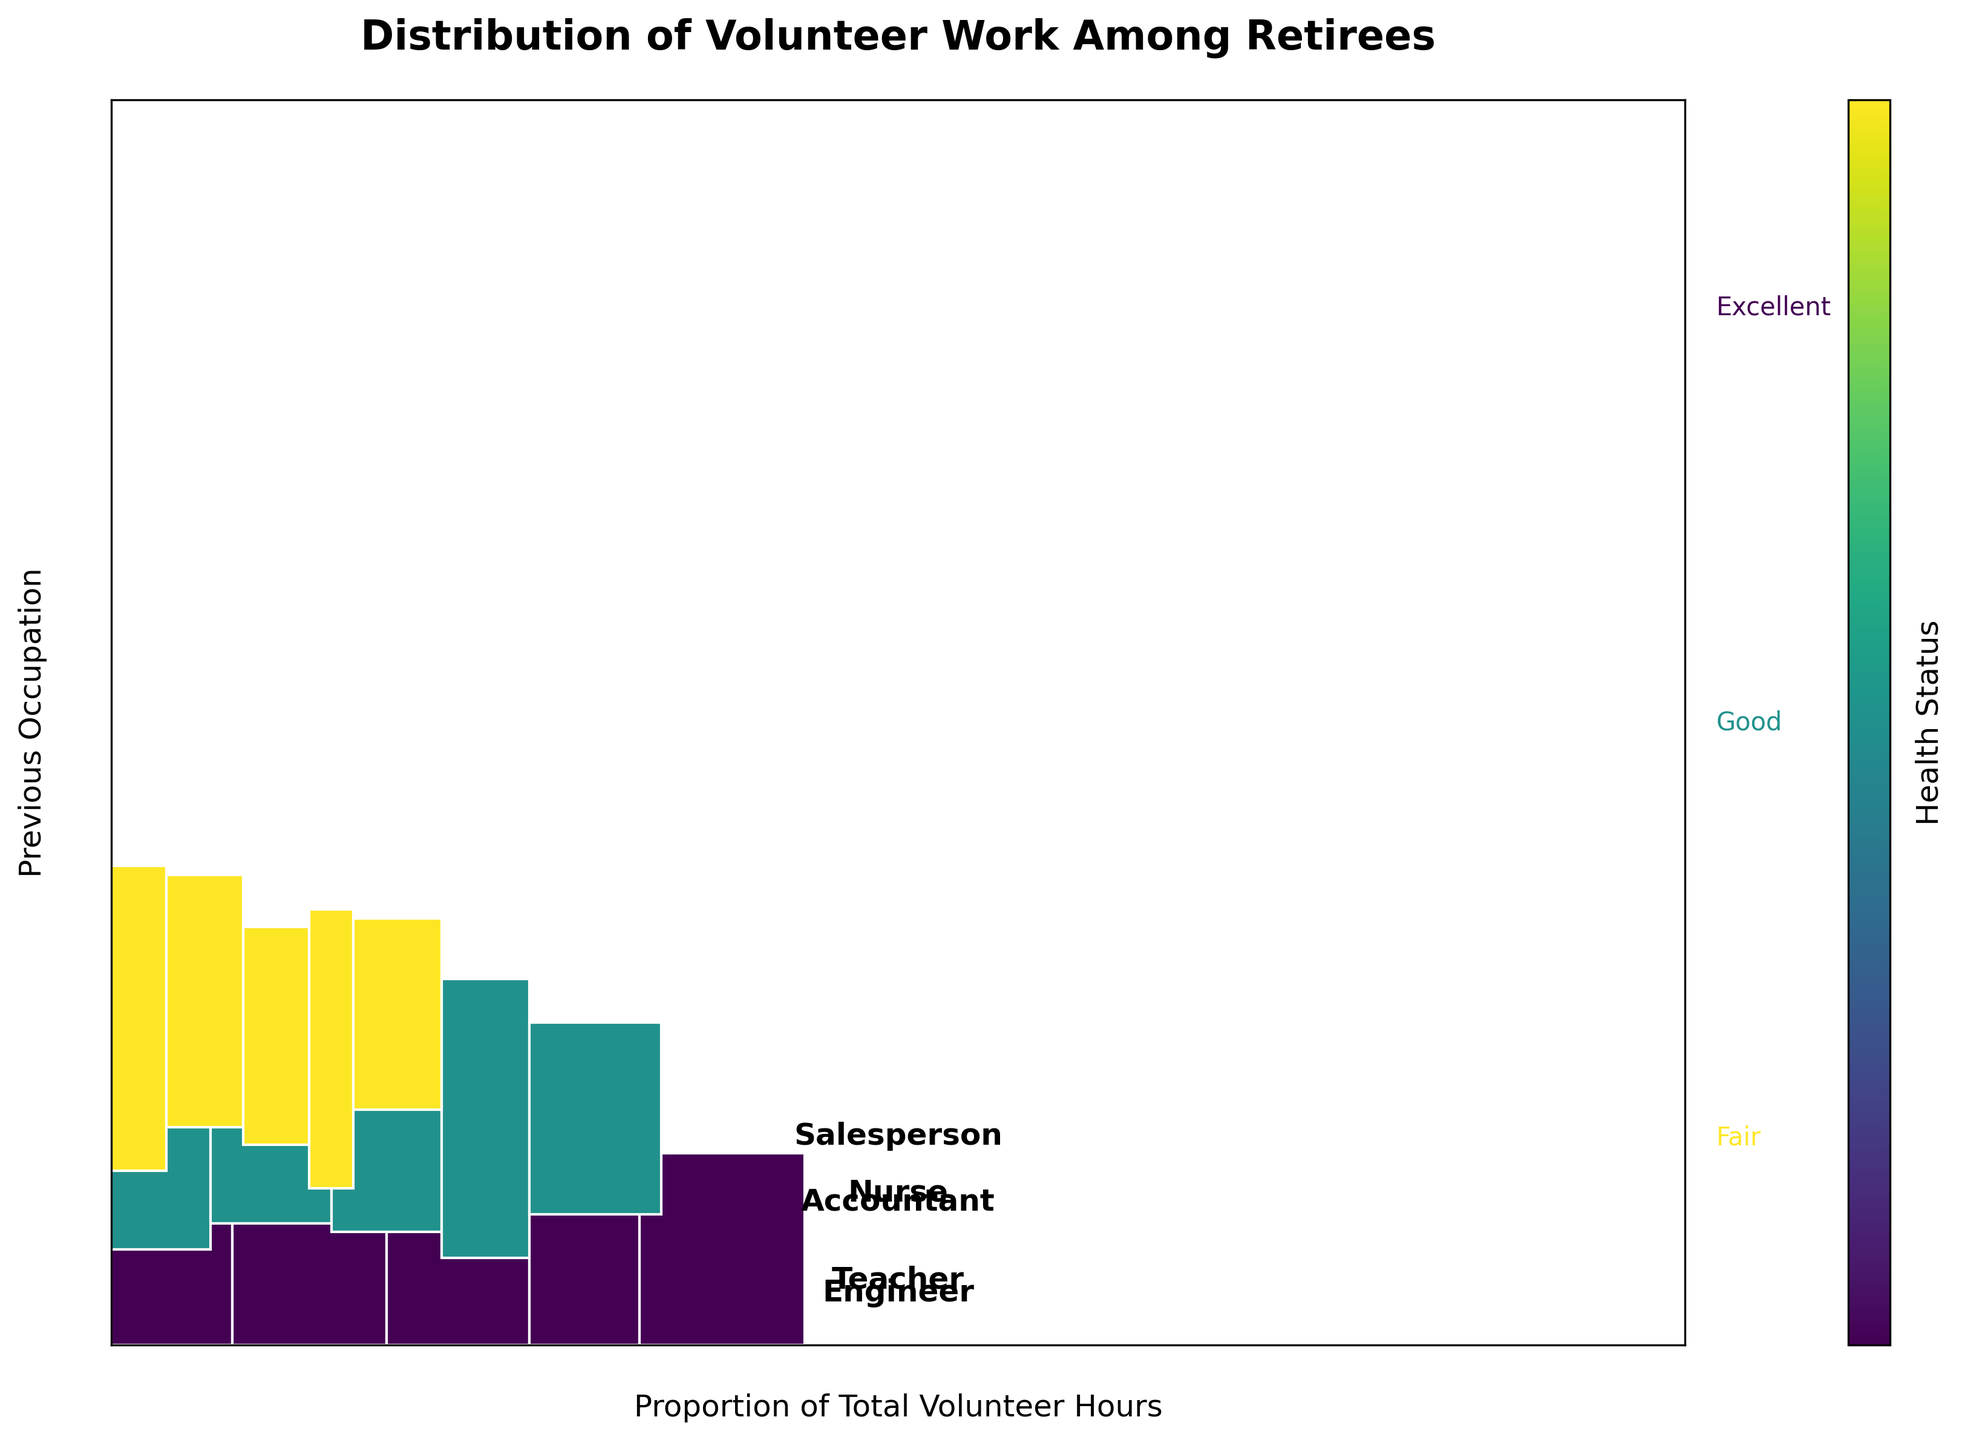What is the title of the mosaic plot? The title of the mosaic plot is displayed at the top of the figure in bold and larger font compared to other text elements. It gives an overview of what the plot is depicting.
Answer: Distribution of Volunteer Work Among Retirees Which occupation has the highest proportion of volunteer hours? To find the occupation with the highest proportion, look at the height of the rectangular segments for each occupation. The total height of these segments represents the proportion of volunteer hours for that occupation.
Answer: Teacher What is the proportion of total volunteer hours for retirees in fair health who were accountants? Locate the segment corresponding to accountants with fair health in the mosaic plot. The proportion is depicted by the area of this segment in relation to the total plot area.
Answer: 0.05 Which health status category shows the greatest variety in volunteer hours across different occupations? Examine the width of the segments corresponding to each health status across all occupations. The health status with the most variation in widths indicates the greatest variety.
Answer: Excellent How does the volunteer hour proportion for nurses in good health compare to that for engineers in fair health? Compare the area of the segment for nurses with good health to that for engineers with fair health. These segments can be compared by their widths and heights.
Answer: Nurses in good health have a higher proportion What is the combined proportion of volunteer hours for teachers and engineers in excellent health? Find the widths of the segments for teachers and engineers in excellent health, then sum these widths to find the combined proportion.
Answer: 0.45 Which health status among teachers has the least volunteer hours? Identify the smallest segment (in terms of width) for teachers among the different health statuses.
Answer: Fair Do nurses or accountants contribute more volunteer hours in good health? Compare the width of the segment for nurses in good health with that for accountants in good health to determine which is larger.
Answer: Nurses 